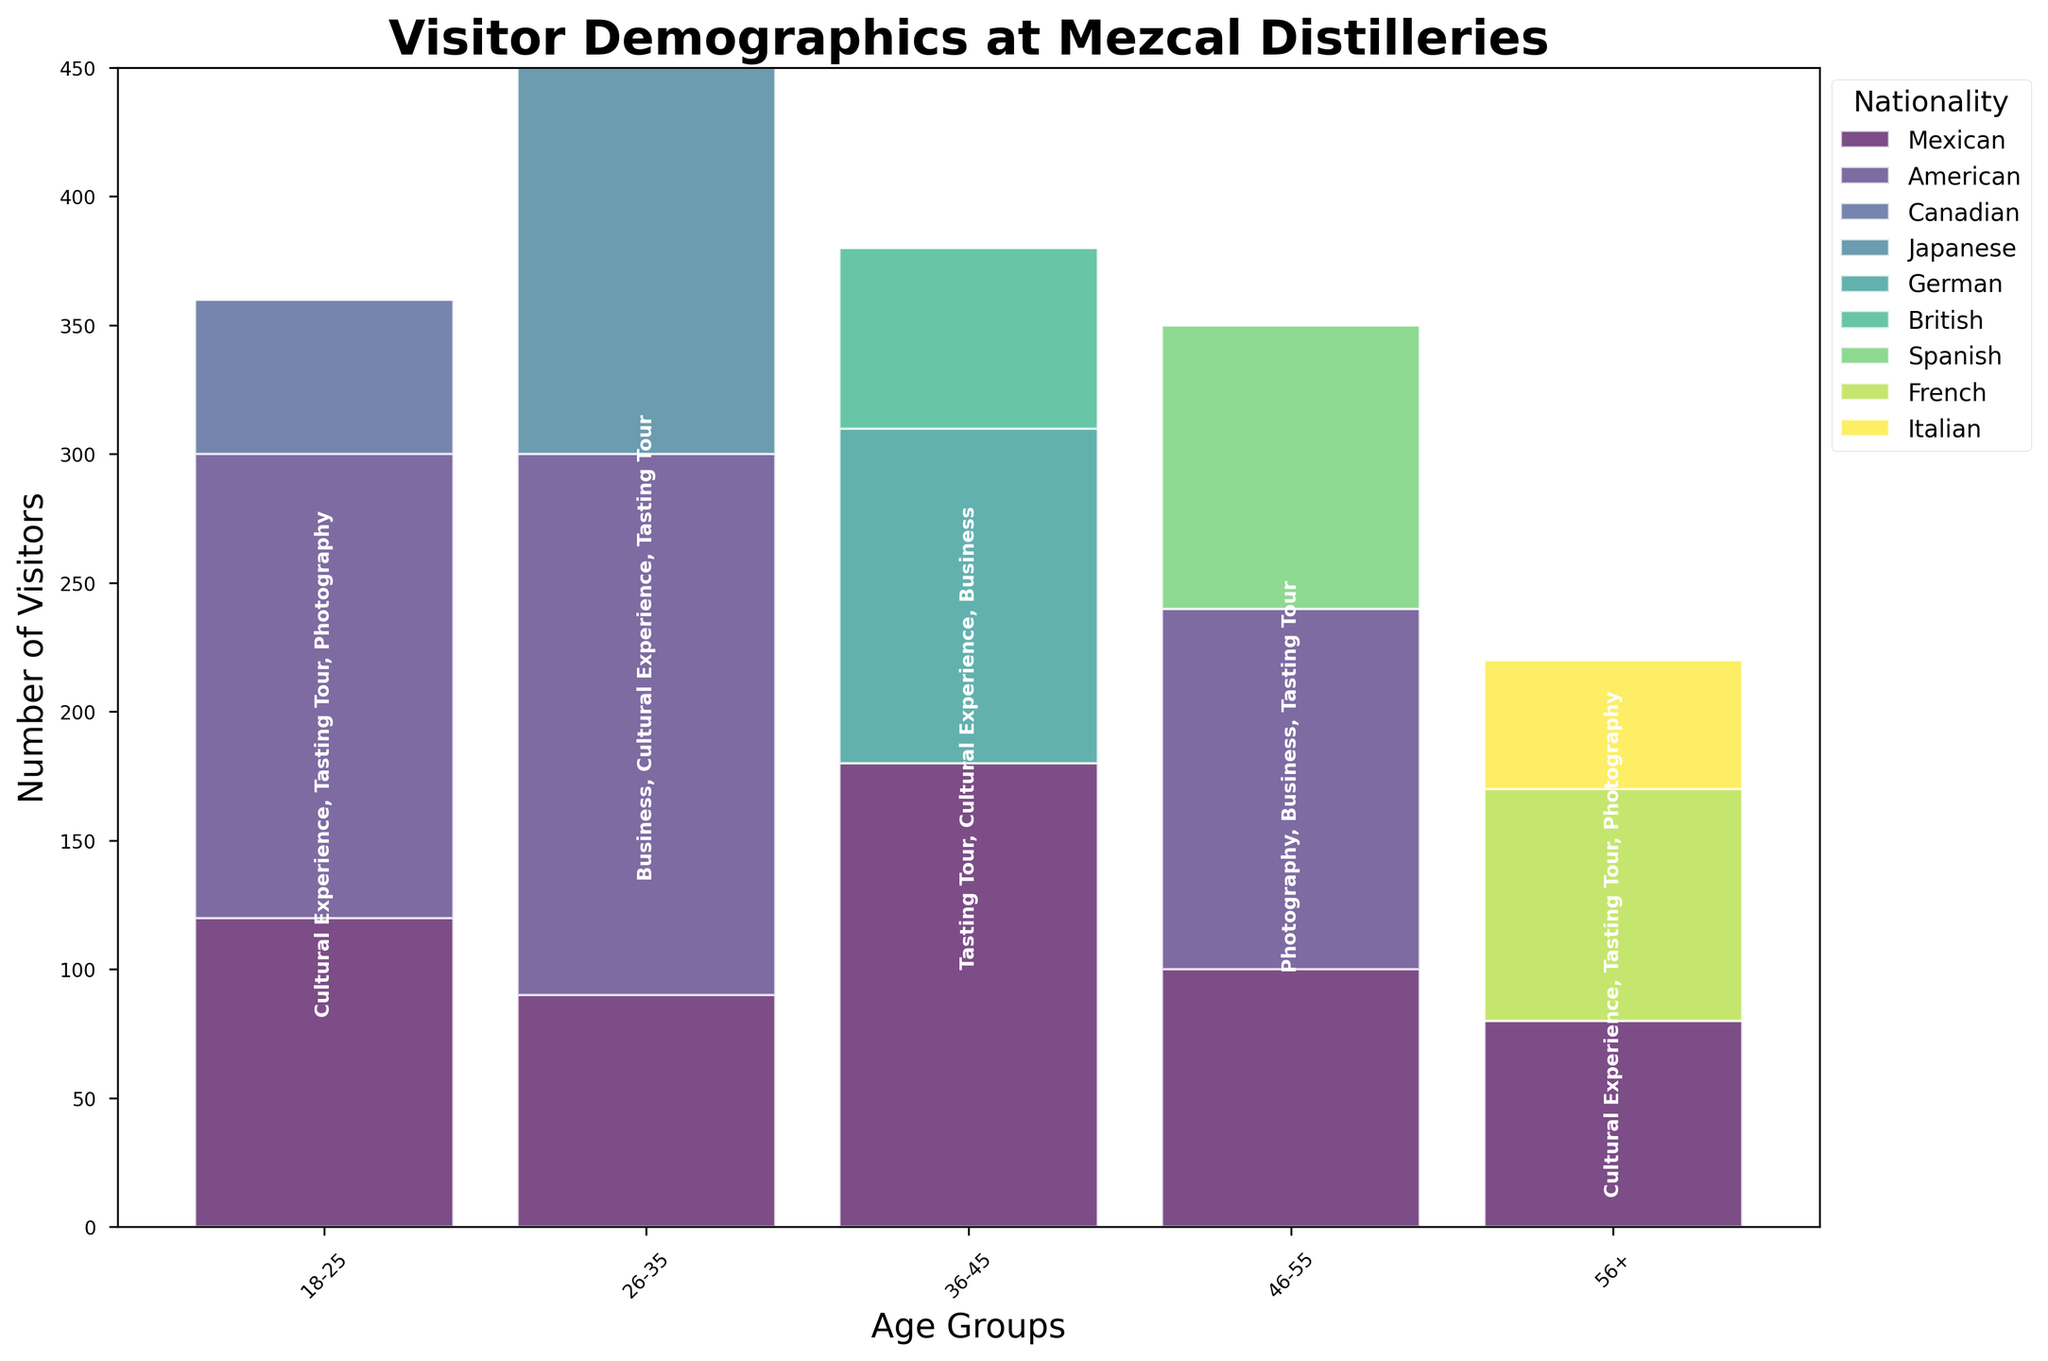What does the title of the plot say? The title at the top of the plot provides a succinct summary of the information being visualized. It states "Visitor Demographics at Mezcal Distilleries" which gives an overview of what the data is about.
Answer: Visitor Demographics at Mezcal Distilleries Which age group has the highest total number of visitors? To find the age group with the highest number of visitors, look at the stacked bars in the mosaic plot for each age group and compare their total heights. Age group 26-35 has the highest stacked bar.
Answer: 26-35 How many nationalities are represented in the plot? Count the distinct colors and the entries in the legend which lists each nationality represented in the plot. There are six nationalities: Mexican, American, Canadian, Japanese, German, British, Spanish, French, and Italian.
Answer: 9 Among the age group 18-25, which nationality has the most visitors? Examine the segments of the bar corresponding to the 18-25 age group and identify which segment (color) is the largest. The American nationality segment is the largest.
Answer: American Which travel purpose appears most frequently in the age group 36-45? Look at the annotations within the bar for the age group 36-45 and see the purposes listed. Compare the counts if necessary. "Tasting Tour" appears most frequently.
Answer: Tasting Tour Compare the number of visitors from Mexico aged 46-55 with those aged 56+. Which group had more visitors and by how much? Check the heights of the corresponding segments (Mexican nationality) for the age groups 46-55 and 56+. 46-55 has 100 visitors, and 56+ has 80 visitors. The difference is 100 - 80 = 20.
Answer: 46-55 by 20 visitors Which nationality has the smallest number of visitors across all age groups? Compare the total segment sizes for each nationality across all age groups. The Italian nationality has the smallest combined size.
Answer: Italian For the age group 26-35, which travel purpose(s) are listed? Read the annotation within the bar for the age group 26-35, which lists the travel purposes. "Business" and "Cultural Experience" are listed for this age group.
Answer: Business, Cultural Experience What is the total number of Japanese visitors? Sum the heights of Japanese visitors across all age groups. Japanese visitors are only found in the age group 26-35 with 150 visitors.
Answer: 150 Which age group has the most diverse set of travel purposes? Check the annotations for each age group and see which one includes the highest number of different travel purposes. The age group 18-25 lists three travel purposes: Cultural Experience, Tasting Tour, and Photography.
Answer: 18-25 